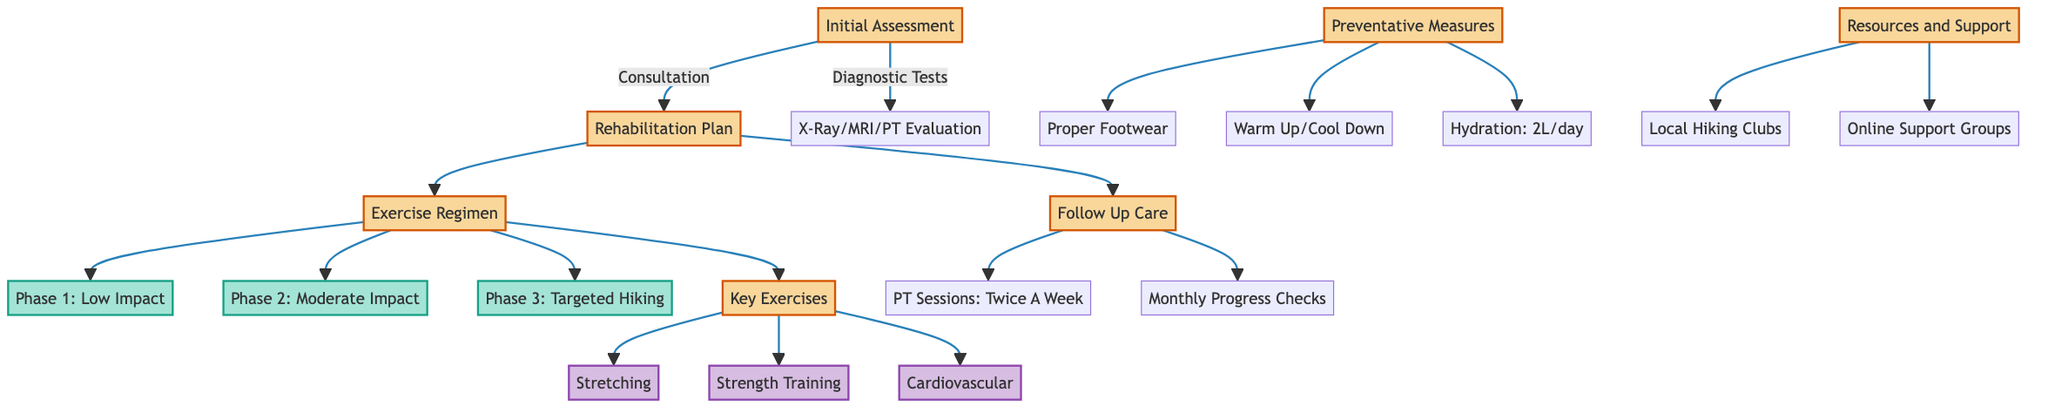What are the two types of consultations in the initial assessment? The diagram lists two consultations: General Physician, which is Dr. Jane Smith, and Orthopedic Specialist, which is Dr. Mark Johnson.
Answer: General Physician, Orthopedic Specialist How many phases are in the exercise regimen? The diagram shows three distinct phases in the exercise regimen: Phase 1, Phase 2, and Phase 3. Therefore, there are three phases.
Answer: 3 What is the frequency of physical therapy sessions in the follow-up care? The diagram specifies that physical therapy sessions occur twice a week in the follow-up care section.
Answer: Twice A Week Which exercise category includes "Leg Press"? The diagram places "Leg Press" under the Strength Training category, which is part of the Key Exercises section.
Answer: Strength Training What are the short-term goals in the rehabilitation plan? The diagram outlines the short-term goals as Pain Management, Swelling Reduction, and Initial Mobility Exercises in the Rehabilitation Plan.
Answer: Pain Management, Swelling Reduction, Initial Mobility Exercises How does the "Preventative Measures" category connect to the rest of the diagram? The Preventative Measures category is separate from other categories but linked to Proper Footwear, Warm Up/Cool Down, and Hydration measures to enhance safety while hiking. It does not directly connect multiple nodes but serves as a precautionary aspect of the pathway.
Answer: N/A What type of exercises are included in Phase 2? According to the diagram, Phase 2 consists of Moderate Impact Exercises as part of the exercise regimen.
Answer: Moderate Impact Exercises What resource is available for local hiking support? The diagram lists the Crowsnest Pass Hiking Club under Local Hiking Clubs as a resource for community support for hikers in the area.
Answer: Crowsnest Pass Hiking Club 